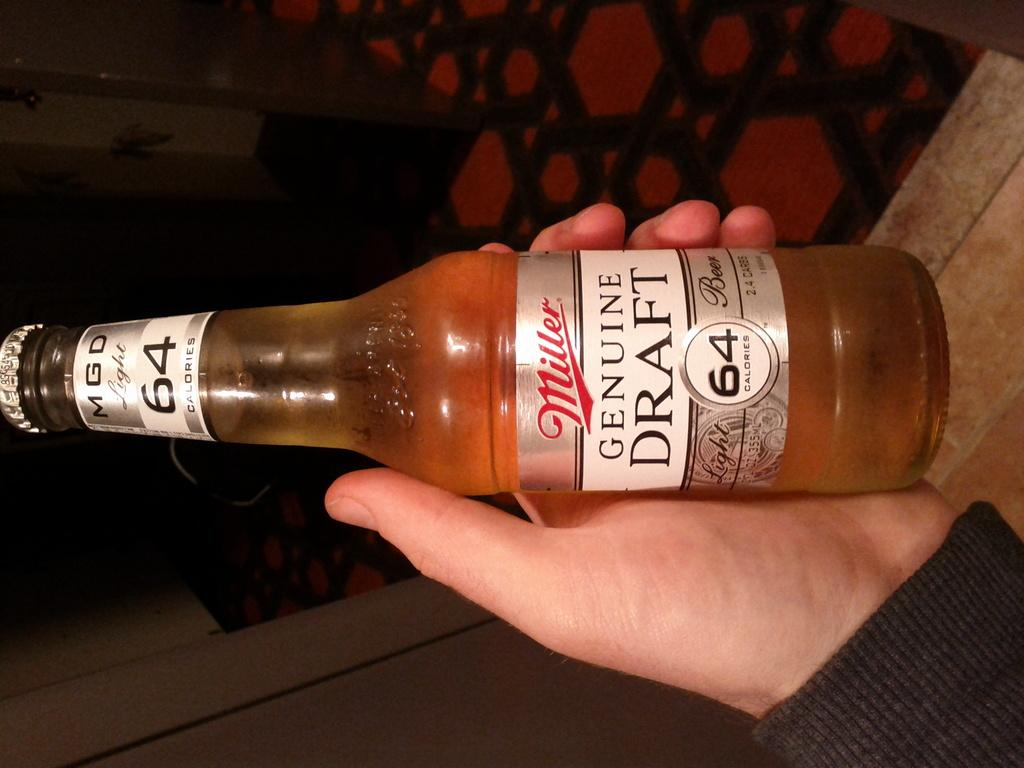<image>
Relay a brief, clear account of the picture shown. A beer from the company Miller Genuine Draft 